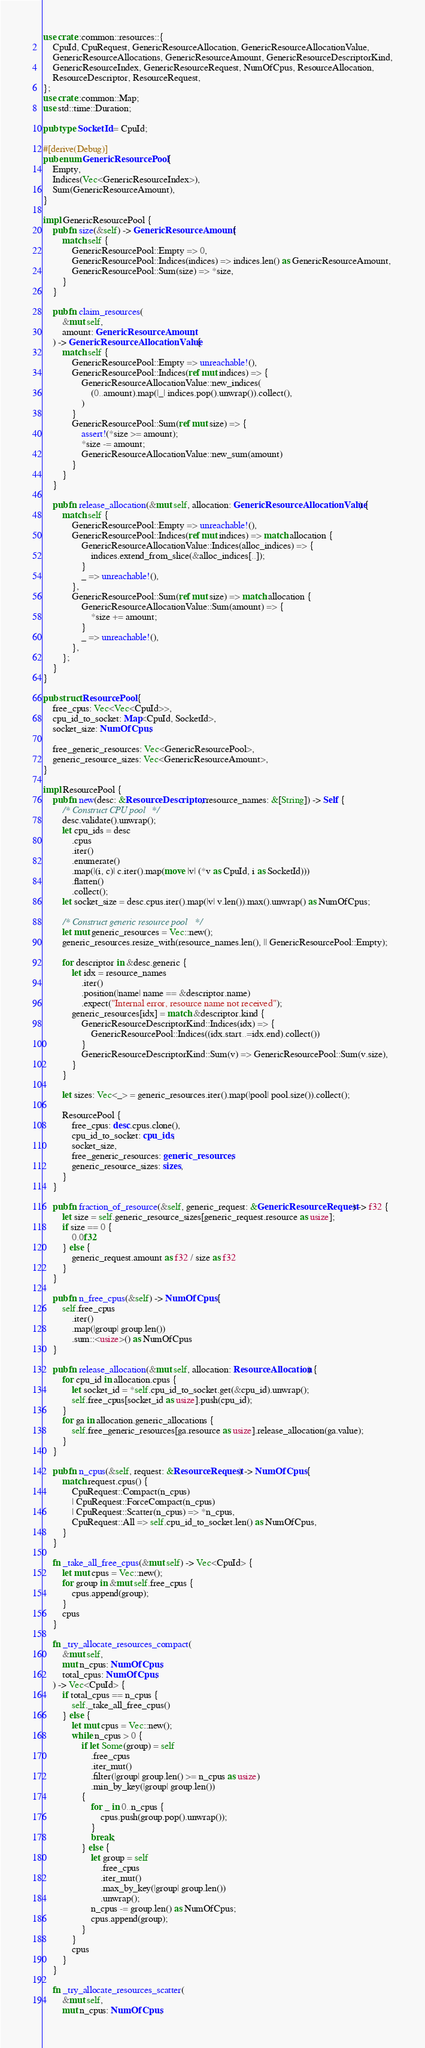Convert code to text. <code><loc_0><loc_0><loc_500><loc_500><_Rust_>use crate::common::resources::{
    CpuId, CpuRequest, GenericResourceAllocation, GenericResourceAllocationValue,
    GenericResourceAllocations, GenericResourceAmount, GenericResourceDescriptorKind,
    GenericResourceIndex, GenericResourceRequest, NumOfCpus, ResourceAllocation,
    ResourceDescriptor, ResourceRequest,
};
use crate::common::Map;
use std::time::Duration;

pub type SocketId = CpuId;

#[derive(Debug)]
pub enum GenericResourcePool {
    Empty,
    Indices(Vec<GenericResourceIndex>),
    Sum(GenericResourceAmount),
}

impl GenericResourcePool {
    pub fn size(&self) -> GenericResourceAmount {
        match self {
            GenericResourcePool::Empty => 0,
            GenericResourcePool::Indices(indices) => indices.len() as GenericResourceAmount,
            GenericResourcePool::Sum(size) => *size,
        }
    }

    pub fn claim_resources(
        &mut self,
        amount: GenericResourceAmount,
    ) -> GenericResourceAllocationValue {
        match self {
            GenericResourcePool::Empty => unreachable!(),
            GenericResourcePool::Indices(ref mut indices) => {
                GenericResourceAllocationValue::new_indices(
                    (0..amount).map(|_| indices.pop().unwrap()).collect(),
                )
            }
            GenericResourcePool::Sum(ref mut size) => {
                assert!(*size >= amount);
                *size -= amount;
                GenericResourceAllocationValue::new_sum(amount)
            }
        }
    }

    pub fn release_allocation(&mut self, allocation: GenericResourceAllocationValue) {
        match self {
            GenericResourcePool::Empty => unreachable!(),
            GenericResourcePool::Indices(ref mut indices) => match allocation {
                GenericResourceAllocationValue::Indices(alloc_indices) => {
                    indices.extend_from_slice(&alloc_indices[..]);
                }
                _ => unreachable!(),
            },
            GenericResourcePool::Sum(ref mut size) => match allocation {
                GenericResourceAllocationValue::Sum(amount) => {
                    *size += amount;
                }
                _ => unreachable!(),
            },
        };
    }
}

pub struct ResourcePool {
    free_cpus: Vec<Vec<CpuId>>,
    cpu_id_to_socket: Map<CpuId, SocketId>,
    socket_size: NumOfCpus,

    free_generic_resources: Vec<GenericResourcePool>,
    generic_resource_sizes: Vec<GenericResourceAmount>,
}

impl ResourcePool {
    pub fn new(desc: &ResourceDescriptor, resource_names: &[String]) -> Self {
        /* Construct CPU pool */
        desc.validate().unwrap();
        let cpu_ids = desc
            .cpus
            .iter()
            .enumerate()
            .map(|(i, c)| c.iter().map(move |v| (*v as CpuId, i as SocketId)))
            .flatten()
            .collect();
        let socket_size = desc.cpus.iter().map(|v| v.len()).max().unwrap() as NumOfCpus;

        /* Construct generic resource pool */
        let mut generic_resources = Vec::new();
        generic_resources.resize_with(resource_names.len(), || GenericResourcePool::Empty);

        for descriptor in &desc.generic {
            let idx = resource_names
                .iter()
                .position(|name| name == &descriptor.name)
                .expect("Internal error, resource name not received");
            generic_resources[idx] = match &descriptor.kind {
                GenericResourceDescriptorKind::Indices(idx) => {
                    GenericResourcePool::Indices((idx.start..=idx.end).collect())
                }
                GenericResourceDescriptorKind::Sum(v) => GenericResourcePool::Sum(v.size),
            }
        }

        let sizes: Vec<_> = generic_resources.iter().map(|pool| pool.size()).collect();

        ResourcePool {
            free_cpus: desc.cpus.clone(),
            cpu_id_to_socket: cpu_ids,
            socket_size,
            free_generic_resources: generic_resources,
            generic_resource_sizes: sizes,
        }
    }

    pub fn fraction_of_resource(&self, generic_request: &GenericResourceRequest) -> f32 {
        let size = self.generic_resource_sizes[generic_request.resource as usize];
        if size == 0 {
            0.0f32
        } else {
            generic_request.amount as f32 / size as f32
        }
    }

    pub fn n_free_cpus(&self) -> NumOfCpus {
        self.free_cpus
            .iter()
            .map(|group| group.len())
            .sum::<usize>() as NumOfCpus
    }

    pub fn release_allocation(&mut self, allocation: ResourceAllocation) {
        for cpu_id in allocation.cpus {
            let socket_id = *self.cpu_id_to_socket.get(&cpu_id).unwrap();
            self.free_cpus[socket_id as usize].push(cpu_id);
        }
        for ga in allocation.generic_allocations {
            self.free_generic_resources[ga.resource as usize].release_allocation(ga.value);
        }
    }

    pub fn n_cpus(&self, request: &ResourceRequest) -> NumOfCpus {
        match request.cpus() {
            CpuRequest::Compact(n_cpus)
            | CpuRequest::ForceCompact(n_cpus)
            | CpuRequest::Scatter(n_cpus) => *n_cpus,
            CpuRequest::All => self.cpu_id_to_socket.len() as NumOfCpus,
        }
    }

    fn _take_all_free_cpus(&mut self) -> Vec<CpuId> {
        let mut cpus = Vec::new();
        for group in &mut self.free_cpus {
            cpus.append(group);
        }
        cpus
    }

    fn _try_allocate_resources_compact(
        &mut self,
        mut n_cpus: NumOfCpus,
        total_cpus: NumOfCpus,
    ) -> Vec<CpuId> {
        if total_cpus == n_cpus {
            self._take_all_free_cpus()
        } else {
            let mut cpus = Vec::new();
            while n_cpus > 0 {
                if let Some(group) = self
                    .free_cpus
                    .iter_mut()
                    .filter(|group| group.len() >= n_cpus as usize)
                    .min_by_key(|group| group.len())
                {
                    for _ in 0..n_cpus {
                        cpus.push(group.pop().unwrap());
                    }
                    break;
                } else {
                    let group = self
                        .free_cpus
                        .iter_mut()
                        .max_by_key(|group| group.len())
                        .unwrap();
                    n_cpus -= group.len() as NumOfCpus;
                    cpus.append(group);
                }
            }
            cpus
        }
    }

    fn _try_allocate_resources_scatter(
        &mut self,
        mut n_cpus: NumOfCpus,</code> 